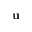Convert formula to latex. <formula><loc_0><loc_0><loc_500><loc_500>{ \mathbf u }</formula> 